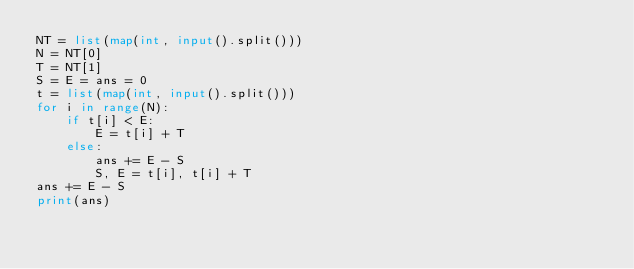Convert code to text. <code><loc_0><loc_0><loc_500><loc_500><_Python_>NT = list(map(int, input().split()))
N = NT[0]
T = NT[1]
S = E = ans = 0
t = list(map(int, input().split()))
for i in range(N):
    if t[i] < E:
        E = t[i] + T
    else:
        ans += E - S
        S, E = t[i], t[i] + T
ans += E - S
print(ans)</code> 